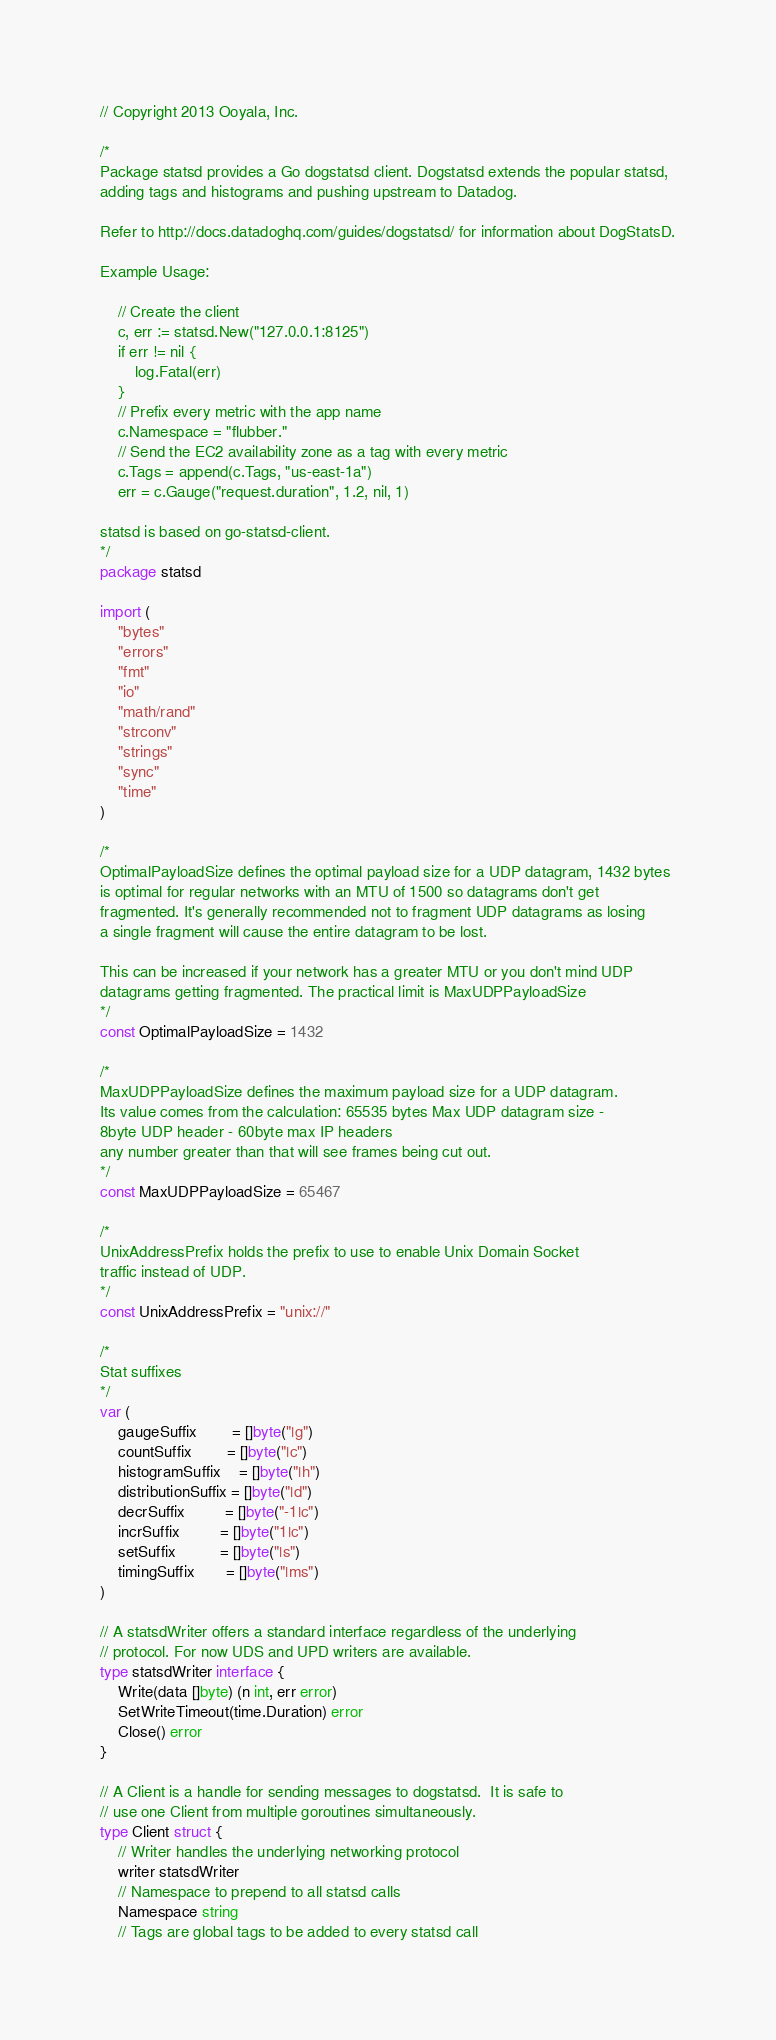Convert code to text. <code><loc_0><loc_0><loc_500><loc_500><_Go_>// Copyright 2013 Ooyala, Inc.

/*
Package statsd provides a Go dogstatsd client. Dogstatsd extends the popular statsd,
adding tags and histograms and pushing upstream to Datadog.

Refer to http://docs.datadoghq.com/guides/dogstatsd/ for information about DogStatsD.

Example Usage:

    // Create the client
    c, err := statsd.New("127.0.0.1:8125")
    if err != nil {
        log.Fatal(err)
    }
    // Prefix every metric with the app name
    c.Namespace = "flubber."
    // Send the EC2 availability zone as a tag with every metric
    c.Tags = append(c.Tags, "us-east-1a")
    err = c.Gauge("request.duration", 1.2, nil, 1)

statsd is based on go-statsd-client.
*/
package statsd

import (
	"bytes"
	"errors"
	"fmt"
	"io"
	"math/rand"
	"strconv"
	"strings"
	"sync"
	"time"
)

/*
OptimalPayloadSize defines the optimal payload size for a UDP datagram, 1432 bytes
is optimal for regular networks with an MTU of 1500 so datagrams don't get
fragmented. It's generally recommended not to fragment UDP datagrams as losing
a single fragment will cause the entire datagram to be lost.

This can be increased if your network has a greater MTU or you don't mind UDP
datagrams getting fragmented. The practical limit is MaxUDPPayloadSize
*/
const OptimalPayloadSize = 1432

/*
MaxUDPPayloadSize defines the maximum payload size for a UDP datagram.
Its value comes from the calculation: 65535 bytes Max UDP datagram size -
8byte UDP header - 60byte max IP headers
any number greater than that will see frames being cut out.
*/
const MaxUDPPayloadSize = 65467

/*
UnixAddressPrefix holds the prefix to use to enable Unix Domain Socket
traffic instead of UDP.
*/
const UnixAddressPrefix = "unix://"

/*
Stat suffixes
*/
var (
	gaugeSuffix        = []byte("|g")
	countSuffix        = []byte("|c")
	histogramSuffix    = []byte("|h")
	distributionSuffix = []byte("|d")
	decrSuffix         = []byte("-1|c")
	incrSuffix         = []byte("1|c")
	setSuffix          = []byte("|s")
	timingSuffix       = []byte("|ms")
)

// A statsdWriter offers a standard interface regardless of the underlying
// protocol. For now UDS and UPD writers are available.
type statsdWriter interface {
	Write(data []byte) (n int, err error)
	SetWriteTimeout(time.Duration) error
	Close() error
}

// A Client is a handle for sending messages to dogstatsd.  It is safe to
// use one Client from multiple goroutines simultaneously.
type Client struct {
	// Writer handles the underlying networking protocol
	writer statsdWriter
	// Namespace to prepend to all statsd calls
	Namespace string
	// Tags are global tags to be added to every statsd call</code> 